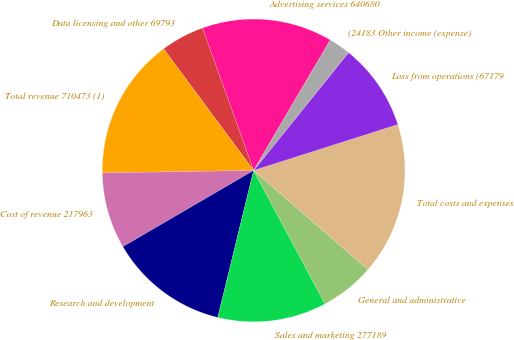Convert chart. <chart><loc_0><loc_0><loc_500><loc_500><pie_chart><fcel>Advertising services 640680<fcel>Data licensing and other 69793<fcel>Total revenue 710473 (1)<fcel>Cost of revenue 217963<fcel>Research and development<fcel>Sales and marketing 277189<fcel>General and administrative<fcel>Total costs and expenses<fcel>Loss from operations (67179<fcel>(24183 Other income (expense)<nl><fcel>13.95%<fcel>4.65%<fcel>15.12%<fcel>8.14%<fcel>12.79%<fcel>11.63%<fcel>5.81%<fcel>16.28%<fcel>9.3%<fcel>2.33%<nl></chart> 